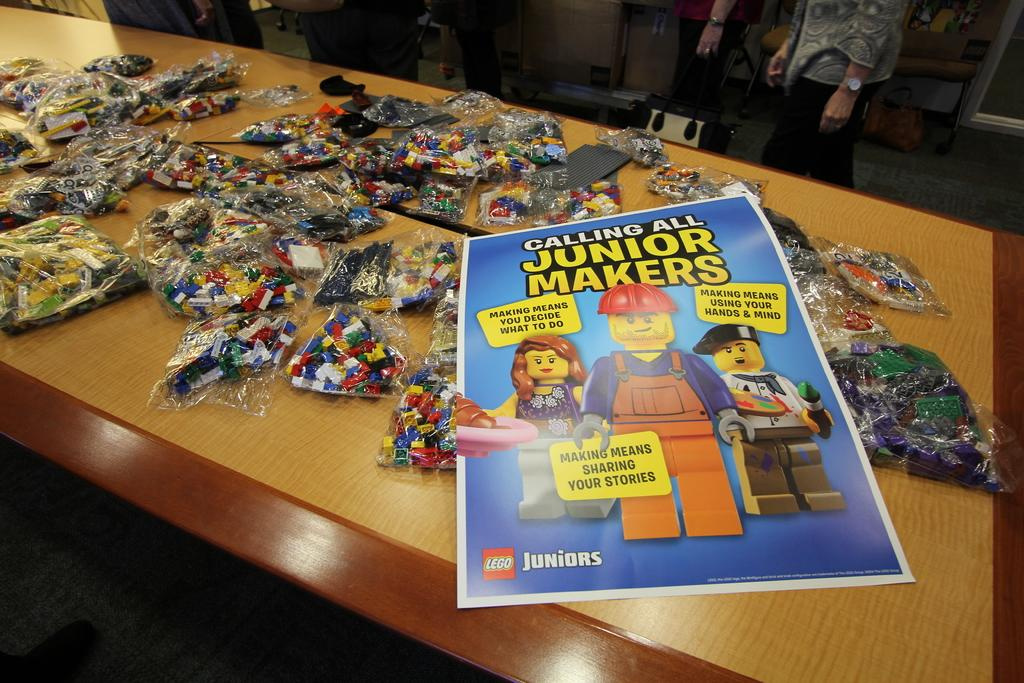What type of furniture is present in the image? There is a table in the image. Can you describe the person in the image? There is a person in the image. What is placed on the table in the image? There is a poster and building boxes on the table. How many friends are sitting inside the tent with the person in the image? There is no tent present in the image, so it is not possible to answer that question. 